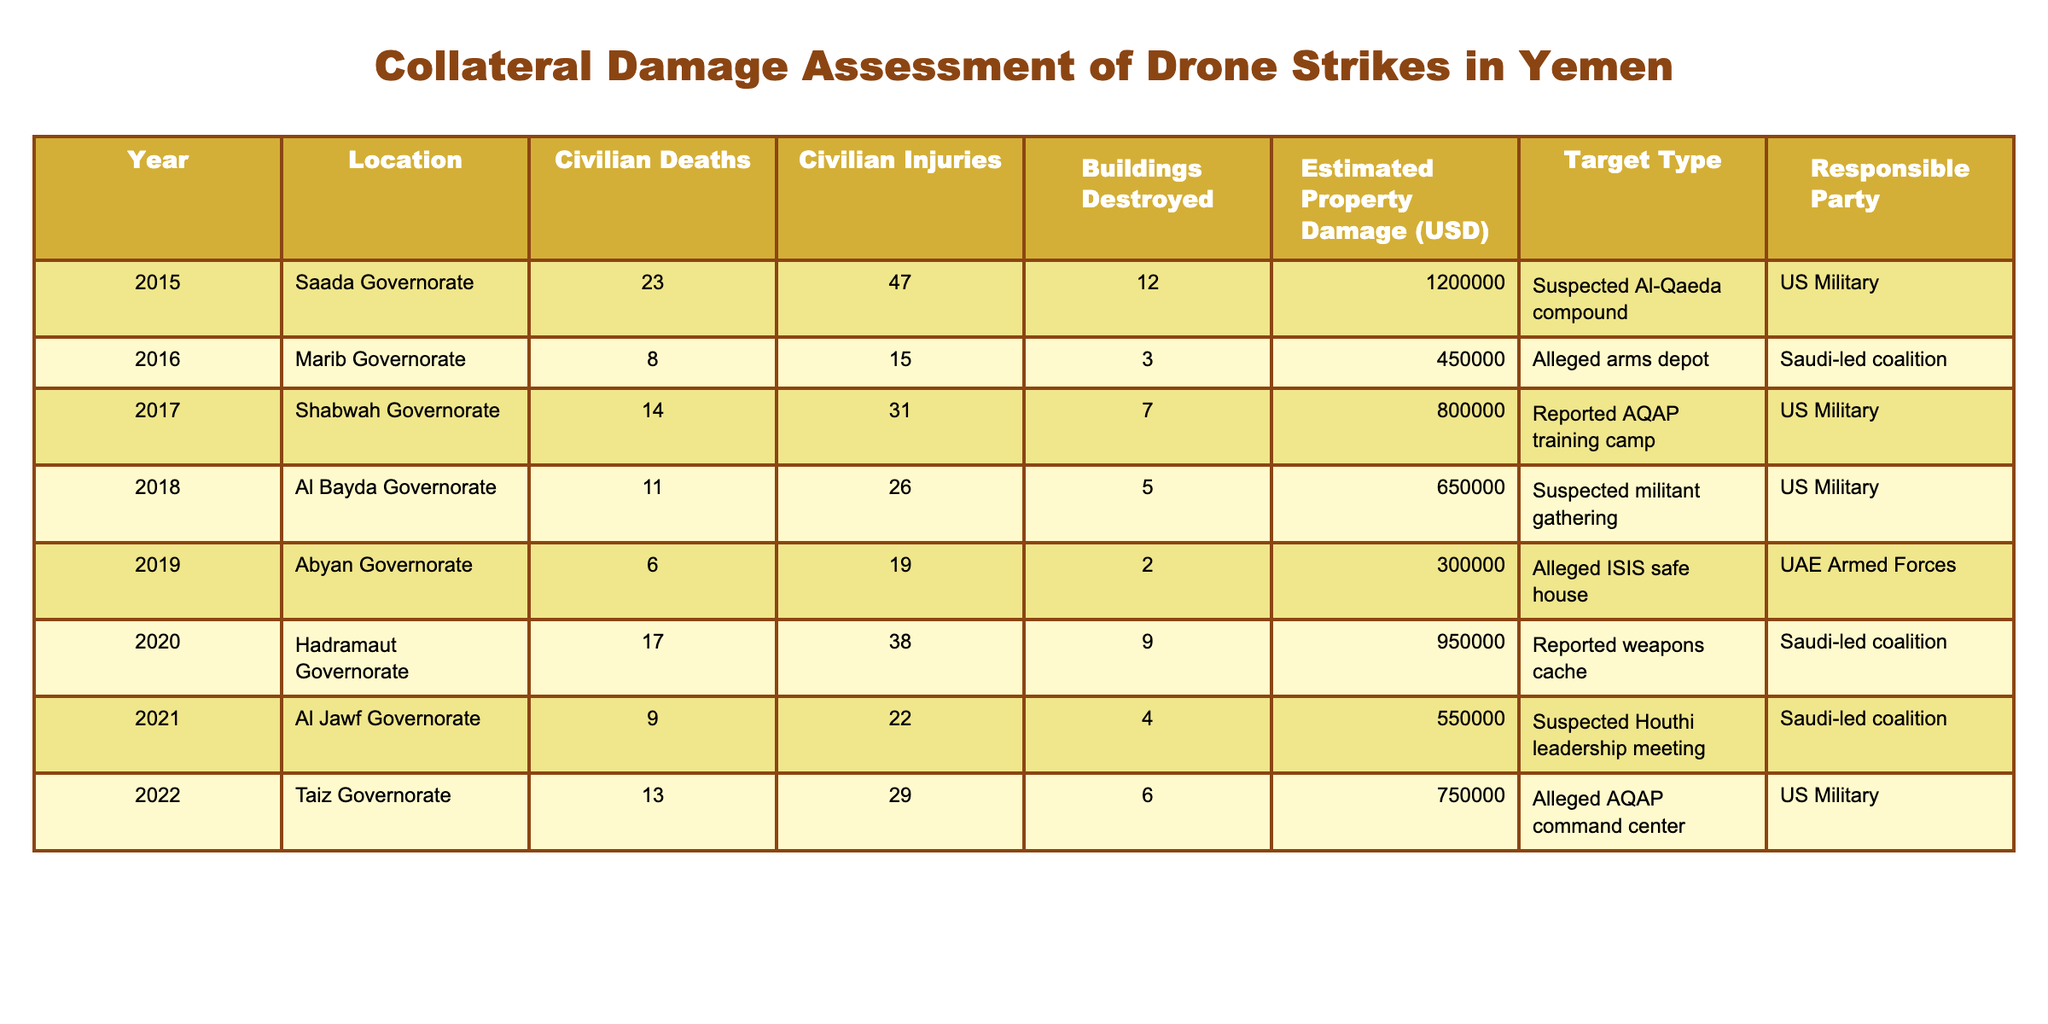What year had the highest number of civilian deaths? By reviewing the "Civilian Deaths" column, we see that the year with the highest number is 2015, which recorded 23 civilian deaths.
Answer: 2015 Which responsible party caused the least civilian injuries? Looking at the "Civilian Injuries" column, we find that in 2019, the UAE Armed Forces reported the least injuries, with a total of 19.
Answer: UAE Armed Forces What is the total estimated property damage from all the listed drone strikes? Summing the "Estimated Property Damage (USD)" column gives us a total of 1200000 + 450000 + 800000 + 650000 + 300000 + 950000 + 550000 + 750000 = 5200000.
Answer: 5200000 Which location suffered the most buildings destroyed in a single year? Checking the "Buildings Destroyed" column, the highest value is 12 in the Saada Governorate in 2015.
Answer: Saada Governorate in 2015 Did the US Military ever strike a target that caused more civilian injuries than deaths? Comparing the civilian injuries and deaths for each strike by the US Military, we see in 2018 that there were 26 injuries and 11 deaths, which satisfies this condition.
Answer: Yes What was the average number of civilian deaths for drone strikes conducted by the Saudi-led coalition? The Saudi-led coalition conducted strikes in 2016 (8 deaths), 2020 (17 deaths), and 2021 (9 deaths). The total deaths are 8 + 17 + 9 = 34. There are 3 strikes, so the average is 34 / 3 = 11.33, rounded to 11.
Answer: 11 In how many years did the US Military conduct drone strikes resulting in civilian casualties of 10 or more? Reviewing the "Civilian Deaths" column for the US Military, we find 2015 (23), 2017 (14), 2018 (11), and 2022 (13), which makes 4 years in total.
Answer: 4 What is the difference between the highest and lowest estimated property damage in the table? The highest damage is 1200000 (2015), and the lowest is 300000 (2019). The difference is 1200000 - 300000 = 900000.
Answer: 900000 Which target type resulted in the most civilian injuries overall? Calculating injuries for each target type, the highest total comes from "Suspected Houthi leadership meeting" (22 injuries) and "Suspected Al-Qaeda compound" (47 injuries), giving a combined total of 69 injuries.
Answer: Suspected Al-Qaeda compound What percentage of civilian deaths occurred in the Shabwah Governorate compared to the total deaths? The total civilian deaths amount to (23 + 8 + 14 + 11 + 6 + 17 + 9 + 13) = 101. The Shabwah Governorate has 14 deaths, so (14 / 101) * 100 ≈ 13.86%.
Answer: 13.86% 